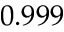Convert formula to latex. <formula><loc_0><loc_0><loc_500><loc_500>0 . 9 9 9</formula> 